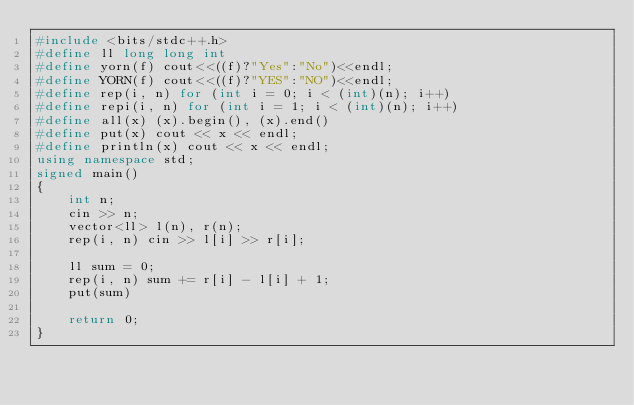<code> <loc_0><loc_0><loc_500><loc_500><_C++_>#include <bits/stdc++.h>
#define ll long long int
#define yorn(f) cout<<((f)?"Yes":"No")<<endl;
#define YORN(f) cout<<((f)?"YES":"NO")<<endl;
#define rep(i, n) for (int i = 0; i < (int)(n); i++)
#define repi(i, n) for (int i = 1; i < (int)(n); i++)
#define all(x) (x).begin(), (x).end()
#define put(x) cout << x << endl;
#define println(x) cout << x << endl;
using namespace std;
signed main()
{
    int n;
    cin >> n;
    vector<ll> l(n), r(n);
    rep(i, n) cin >> l[i] >> r[i];
    
    ll sum = 0;
    rep(i, n) sum += r[i] - l[i] + 1;
    put(sum)

    return 0;
}</code> 